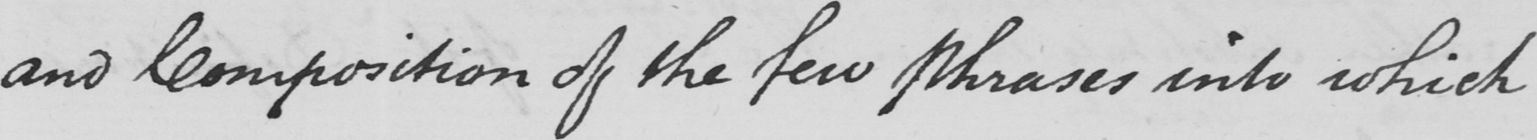What does this handwritten line say? and Composition of the few Phrases into which 